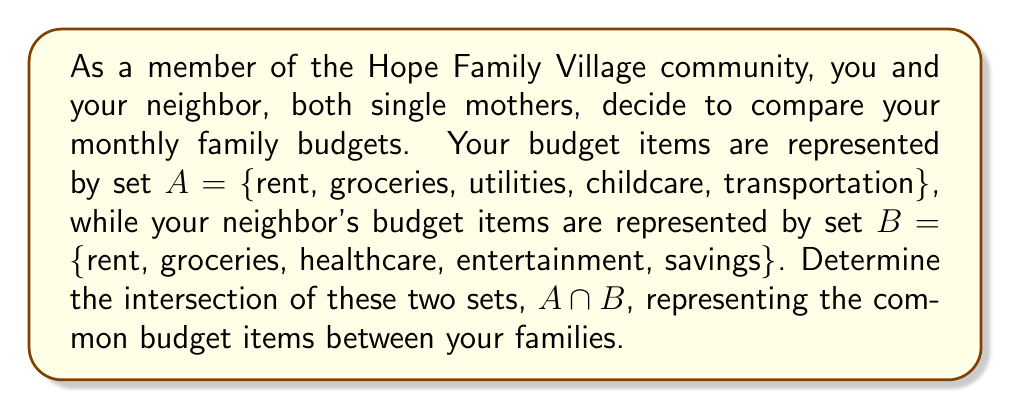Help me with this question. To find the intersection of two sets, we need to identify the elements that are common to both sets. Let's analyze the given sets:

Set $A = \{$rent, groceries, utilities, childcare, transportation$\}$
Set $B = \{$rent, groceries, healthcare, entertainment, savings$\}$

To determine $A \cap B$, we compare each element in set $A$ with the elements in set $B$:

1. "rent" is present in both $A$ and $B$
2. "groceries" is present in both $A$ and $B$
3. "utilities" is only in $A$
4. "childcare" is only in $A$
5. "transportation" is only in $A$
6. "healthcare" is only in $B$
7. "entertainment" is only in $B$
8. "savings" is only in $B$

The elements that appear in both sets are "rent" and "groceries". Therefore, these two items form the intersection of sets $A$ and $B$.
Answer: $A \cap B = \{$rent, groceries$\}$ 